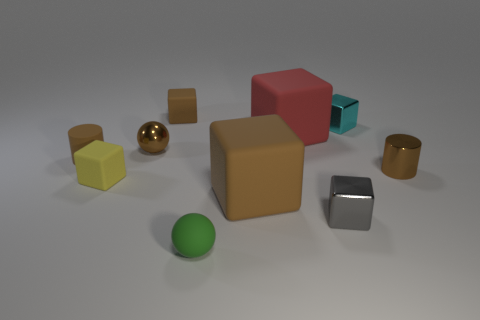Subtract all gray blocks. How many blocks are left? 5 Subtract all big cubes. How many cubes are left? 4 Subtract 3 cubes. How many cubes are left? 3 Subtract all green blocks. Subtract all blue cylinders. How many blocks are left? 6 Subtract all cylinders. How many objects are left? 8 Subtract 0 green blocks. How many objects are left? 10 Subtract all tiny brown shiny cylinders. Subtract all large rubber blocks. How many objects are left? 7 Add 3 tiny gray things. How many tiny gray things are left? 4 Add 2 brown matte objects. How many brown matte objects exist? 5 